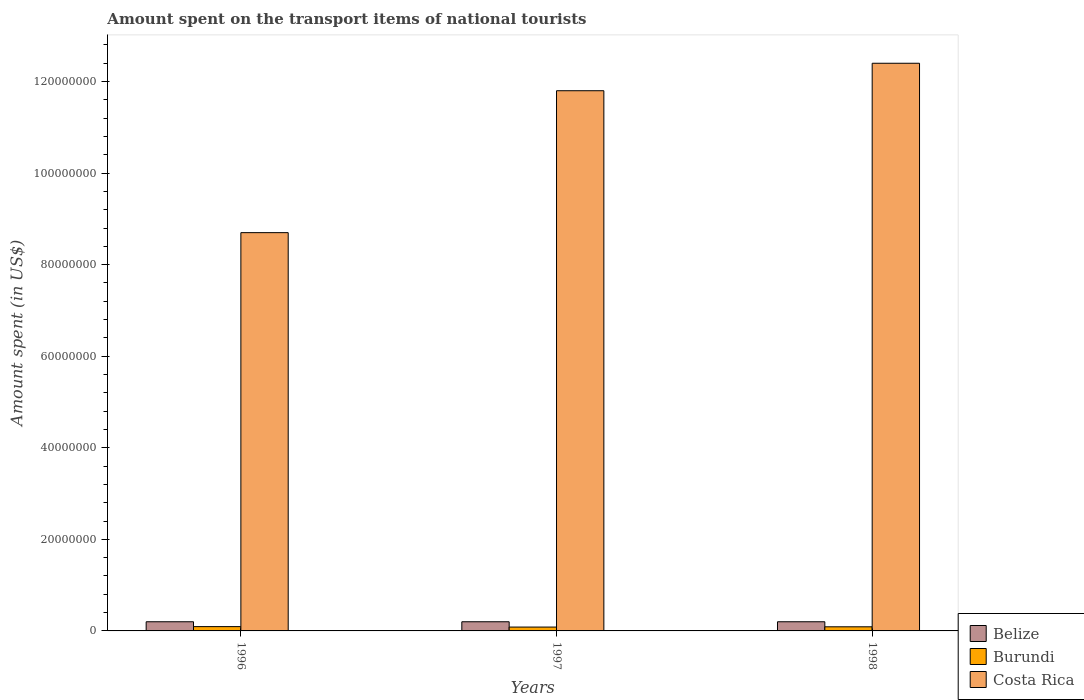Are the number of bars per tick equal to the number of legend labels?
Provide a succinct answer. Yes. In how many cases, is the number of bars for a given year not equal to the number of legend labels?
Your answer should be very brief. 0. What is the amount spent on the transport items of national tourists in Costa Rica in 1998?
Offer a very short reply. 1.24e+08. Across all years, what is the maximum amount spent on the transport items of national tourists in Costa Rica?
Keep it short and to the point. 1.24e+08. Across all years, what is the minimum amount spent on the transport items of national tourists in Burundi?
Keep it short and to the point. 8.40e+05. In which year was the amount spent on the transport items of national tourists in Costa Rica maximum?
Your answer should be very brief. 1998. What is the total amount spent on the transport items of national tourists in Burundi in the graph?
Your answer should be compact. 2.68e+06. What is the difference between the amount spent on the transport items of national tourists in Costa Rica in 1996 and that in 1998?
Give a very brief answer. -3.70e+07. What is the difference between the amount spent on the transport items of national tourists in Belize in 1998 and the amount spent on the transport items of national tourists in Burundi in 1996?
Keep it short and to the point. 1.06e+06. What is the average amount spent on the transport items of national tourists in Costa Rica per year?
Your answer should be compact. 1.10e+08. In the year 1998, what is the difference between the amount spent on the transport items of national tourists in Burundi and amount spent on the transport items of national tourists in Costa Rica?
Provide a short and direct response. -1.23e+08. Is the amount spent on the transport items of national tourists in Belize in 1996 less than that in 1998?
Offer a terse response. No. In how many years, is the amount spent on the transport items of national tourists in Belize greater than the average amount spent on the transport items of national tourists in Belize taken over all years?
Your answer should be very brief. 0. Is the sum of the amount spent on the transport items of national tourists in Costa Rica in 1997 and 1998 greater than the maximum amount spent on the transport items of national tourists in Belize across all years?
Keep it short and to the point. Yes. What does the 3rd bar from the left in 1998 represents?
Keep it short and to the point. Costa Rica. What does the 1st bar from the right in 1997 represents?
Make the answer very short. Costa Rica. Is it the case that in every year, the sum of the amount spent on the transport items of national tourists in Costa Rica and amount spent on the transport items of national tourists in Burundi is greater than the amount spent on the transport items of national tourists in Belize?
Give a very brief answer. Yes. What is the difference between two consecutive major ticks on the Y-axis?
Your answer should be very brief. 2.00e+07. Are the values on the major ticks of Y-axis written in scientific E-notation?
Offer a terse response. No. Does the graph contain grids?
Your answer should be very brief. No. Where does the legend appear in the graph?
Make the answer very short. Bottom right. How are the legend labels stacked?
Provide a succinct answer. Vertical. What is the title of the graph?
Your response must be concise. Amount spent on the transport items of national tourists. What is the label or title of the Y-axis?
Keep it short and to the point. Amount spent (in US$). What is the Amount spent (in US$) of Belize in 1996?
Give a very brief answer. 2.00e+06. What is the Amount spent (in US$) of Burundi in 1996?
Offer a very short reply. 9.41e+05. What is the Amount spent (in US$) in Costa Rica in 1996?
Your response must be concise. 8.70e+07. What is the Amount spent (in US$) in Belize in 1997?
Your response must be concise. 2.00e+06. What is the Amount spent (in US$) of Burundi in 1997?
Offer a terse response. 8.40e+05. What is the Amount spent (in US$) in Costa Rica in 1997?
Give a very brief answer. 1.18e+08. What is the Amount spent (in US$) of Belize in 1998?
Give a very brief answer. 2.00e+06. What is the Amount spent (in US$) of Burundi in 1998?
Ensure brevity in your answer.  9.00e+05. What is the Amount spent (in US$) in Costa Rica in 1998?
Give a very brief answer. 1.24e+08. Across all years, what is the maximum Amount spent (in US$) of Belize?
Keep it short and to the point. 2.00e+06. Across all years, what is the maximum Amount spent (in US$) of Burundi?
Offer a terse response. 9.41e+05. Across all years, what is the maximum Amount spent (in US$) in Costa Rica?
Your answer should be very brief. 1.24e+08. Across all years, what is the minimum Amount spent (in US$) of Belize?
Ensure brevity in your answer.  2.00e+06. Across all years, what is the minimum Amount spent (in US$) of Burundi?
Your answer should be very brief. 8.40e+05. Across all years, what is the minimum Amount spent (in US$) of Costa Rica?
Offer a terse response. 8.70e+07. What is the total Amount spent (in US$) of Burundi in the graph?
Ensure brevity in your answer.  2.68e+06. What is the total Amount spent (in US$) of Costa Rica in the graph?
Provide a succinct answer. 3.29e+08. What is the difference between the Amount spent (in US$) in Burundi in 1996 and that in 1997?
Keep it short and to the point. 1.01e+05. What is the difference between the Amount spent (in US$) in Costa Rica in 1996 and that in 1997?
Provide a short and direct response. -3.10e+07. What is the difference between the Amount spent (in US$) in Burundi in 1996 and that in 1998?
Offer a very short reply. 4.14e+04. What is the difference between the Amount spent (in US$) of Costa Rica in 1996 and that in 1998?
Make the answer very short. -3.70e+07. What is the difference between the Amount spent (in US$) of Burundi in 1997 and that in 1998?
Give a very brief answer. -5.99e+04. What is the difference between the Amount spent (in US$) in Costa Rica in 1997 and that in 1998?
Offer a terse response. -6.00e+06. What is the difference between the Amount spent (in US$) in Belize in 1996 and the Amount spent (in US$) in Burundi in 1997?
Ensure brevity in your answer.  1.16e+06. What is the difference between the Amount spent (in US$) in Belize in 1996 and the Amount spent (in US$) in Costa Rica in 1997?
Provide a short and direct response. -1.16e+08. What is the difference between the Amount spent (in US$) of Burundi in 1996 and the Amount spent (in US$) of Costa Rica in 1997?
Give a very brief answer. -1.17e+08. What is the difference between the Amount spent (in US$) of Belize in 1996 and the Amount spent (in US$) of Burundi in 1998?
Keep it short and to the point. 1.10e+06. What is the difference between the Amount spent (in US$) of Belize in 1996 and the Amount spent (in US$) of Costa Rica in 1998?
Your response must be concise. -1.22e+08. What is the difference between the Amount spent (in US$) of Burundi in 1996 and the Amount spent (in US$) of Costa Rica in 1998?
Ensure brevity in your answer.  -1.23e+08. What is the difference between the Amount spent (in US$) in Belize in 1997 and the Amount spent (in US$) in Burundi in 1998?
Your answer should be compact. 1.10e+06. What is the difference between the Amount spent (in US$) of Belize in 1997 and the Amount spent (in US$) of Costa Rica in 1998?
Ensure brevity in your answer.  -1.22e+08. What is the difference between the Amount spent (in US$) in Burundi in 1997 and the Amount spent (in US$) in Costa Rica in 1998?
Offer a terse response. -1.23e+08. What is the average Amount spent (in US$) of Burundi per year?
Ensure brevity in your answer.  8.94e+05. What is the average Amount spent (in US$) in Costa Rica per year?
Ensure brevity in your answer.  1.10e+08. In the year 1996, what is the difference between the Amount spent (in US$) of Belize and Amount spent (in US$) of Burundi?
Make the answer very short. 1.06e+06. In the year 1996, what is the difference between the Amount spent (in US$) of Belize and Amount spent (in US$) of Costa Rica?
Offer a terse response. -8.50e+07. In the year 1996, what is the difference between the Amount spent (in US$) in Burundi and Amount spent (in US$) in Costa Rica?
Your answer should be compact. -8.61e+07. In the year 1997, what is the difference between the Amount spent (in US$) of Belize and Amount spent (in US$) of Burundi?
Keep it short and to the point. 1.16e+06. In the year 1997, what is the difference between the Amount spent (in US$) in Belize and Amount spent (in US$) in Costa Rica?
Offer a terse response. -1.16e+08. In the year 1997, what is the difference between the Amount spent (in US$) of Burundi and Amount spent (in US$) of Costa Rica?
Offer a very short reply. -1.17e+08. In the year 1998, what is the difference between the Amount spent (in US$) in Belize and Amount spent (in US$) in Burundi?
Your response must be concise. 1.10e+06. In the year 1998, what is the difference between the Amount spent (in US$) of Belize and Amount spent (in US$) of Costa Rica?
Ensure brevity in your answer.  -1.22e+08. In the year 1998, what is the difference between the Amount spent (in US$) in Burundi and Amount spent (in US$) in Costa Rica?
Your answer should be very brief. -1.23e+08. What is the ratio of the Amount spent (in US$) of Burundi in 1996 to that in 1997?
Make the answer very short. 1.12. What is the ratio of the Amount spent (in US$) in Costa Rica in 1996 to that in 1997?
Keep it short and to the point. 0.74. What is the ratio of the Amount spent (in US$) of Belize in 1996 to that in 1998?
Give a very brief answer. 1. What is the ratio of the Amount spent (in US$) in Burundi in 1996 to that in 1998?
Provide a succinct answer. 1.05. What is the ratio of the Amount spent (in US$) of Costa Rica in 1996 to that in 1998?
Offer a very short reply. 0.7. What is the ratio of the Amount spent (in US$) in Burundi in 1997 to that in 1998?
Your response must be concise. 0.93. What is the ratio of the Amount spent (in US$) in Costa Rica in 1997 to that in 1998?
Offer a very short reply. 0.95. What is the difference between the highest and the second highest Amount spent (in US$) of Burundi?
Your response must be concise. 4.14e+04. What is the difference between the highest and the lowest Amount spent (in US$) of Belize?
Your response must be concise. 0. What is the difference between the highest and the lowest Amount spent (in US$) of Burundi?
Keep it short and to the point. 1.01e+05. What is the difference between the highest and the lowest Amount spent (in US$) of Costa Rica?
Offer a terse response. 3.70e+07. 